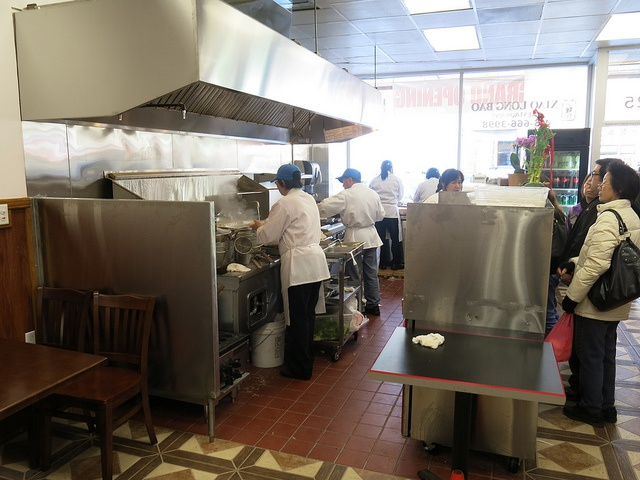Describe the objects in this image and their specific colors. I can see dining table in beige, black, and gray tones, people in beige, black, tan, and gray tones, chair in beige, black, gray, and olive tones, people in beige, black, darkgray, and gray tones, and dining table in beige, black, maroon, and gray tones in this image. 